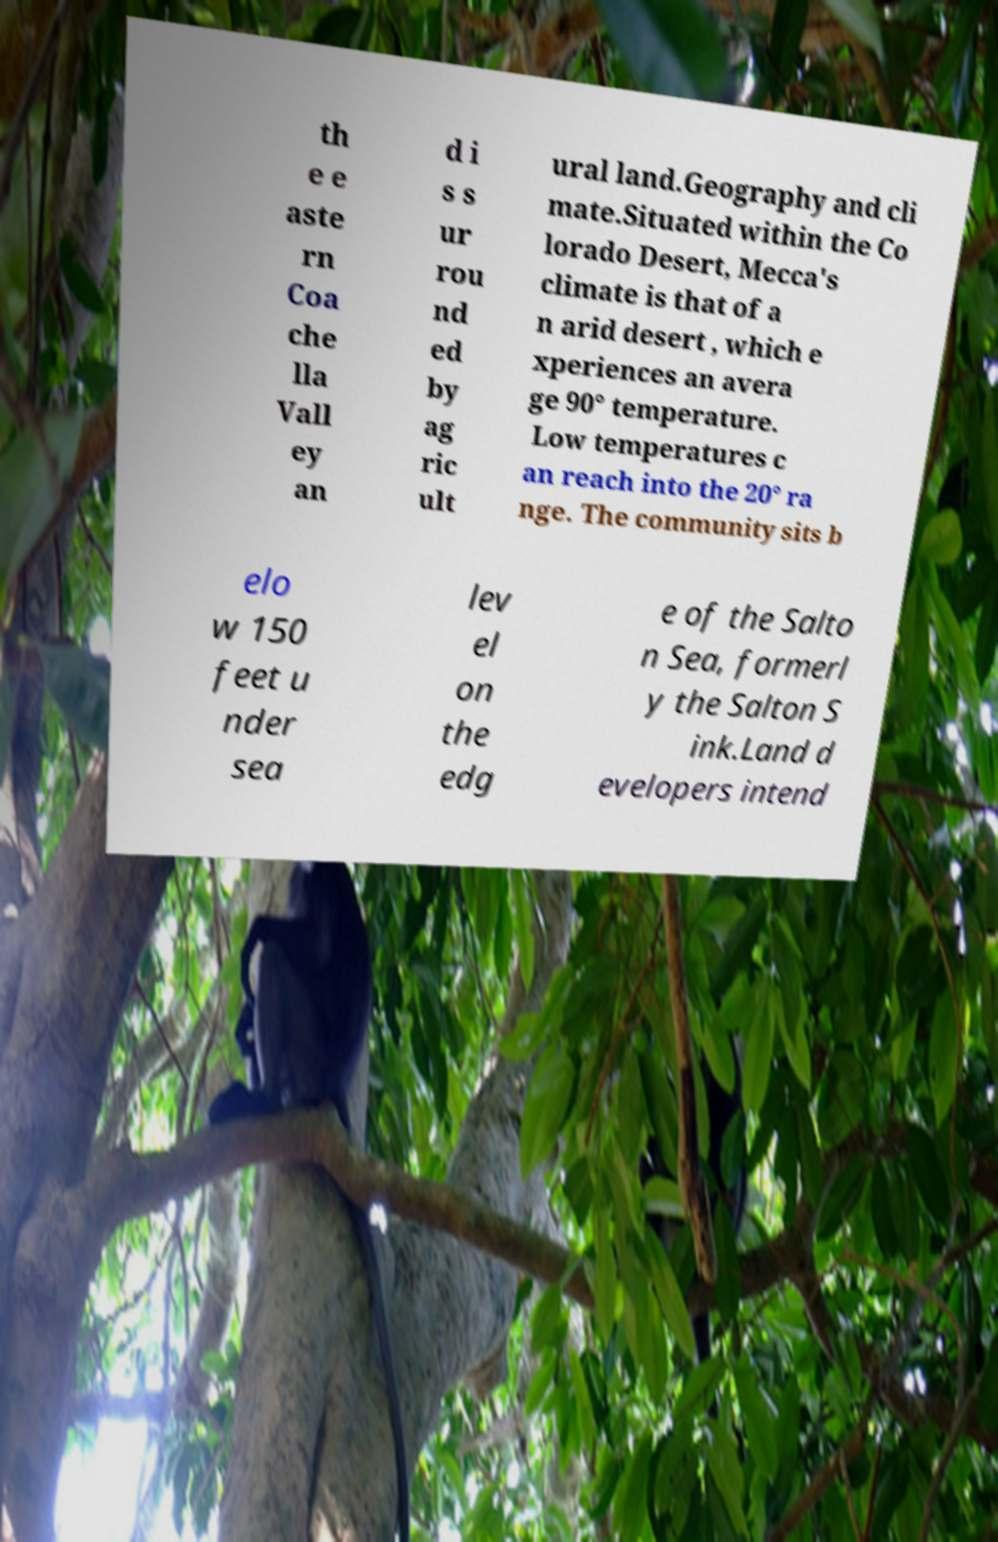Could you extract and type out the text from this image? th e e aste rn Coa che lla Vall ey an d i s s ur rou nd ed by ag ric ult ural land.Geography and cli mate.Situated within the Co lorado Desert, Mecca's climate is that of a n arid desert , which e xperiences an avera ge 90° temperature. Low temperatures c an reach into the 20° ra nge. The community sits b elo w 150 feet u nder sea lev el on the edg e of the Salto n Sea, formerl y the Salton S ink.Land d evelopers intend 